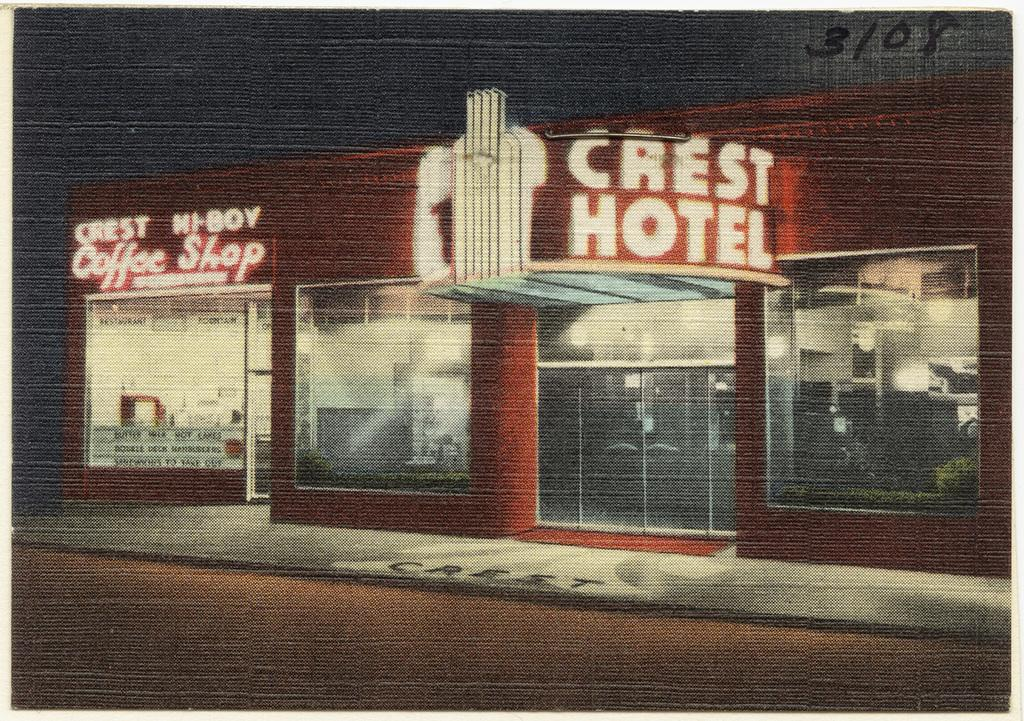What is featured in the image? There is a poster and a building in the image. What can be seen on the poster? There are numbers on the poster. What type of family is depicted on the poster? There is no family depicted on the poster; it only features numbers. What kind of approval is shown on the poster? There is no approval shown on the poster; it only features numbers. 